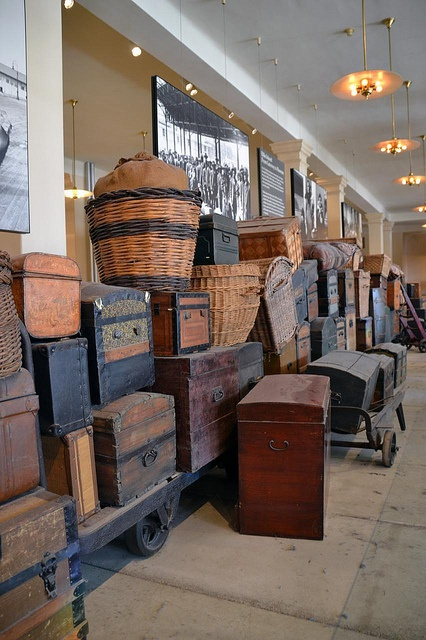Describe the objects in this image and their specific colors. I can see suitcase in darkgray, black, maroon, and gray tones, suitcase in darkgray, gray, black, and darkblue tones, suitcase in darkgray, gray, maroon, and black tones, suitcase in darkgray, black, gray, maroon, and tan tones, and suitcase in darkgray, brown, black, maroon, and gray tones in this image. 